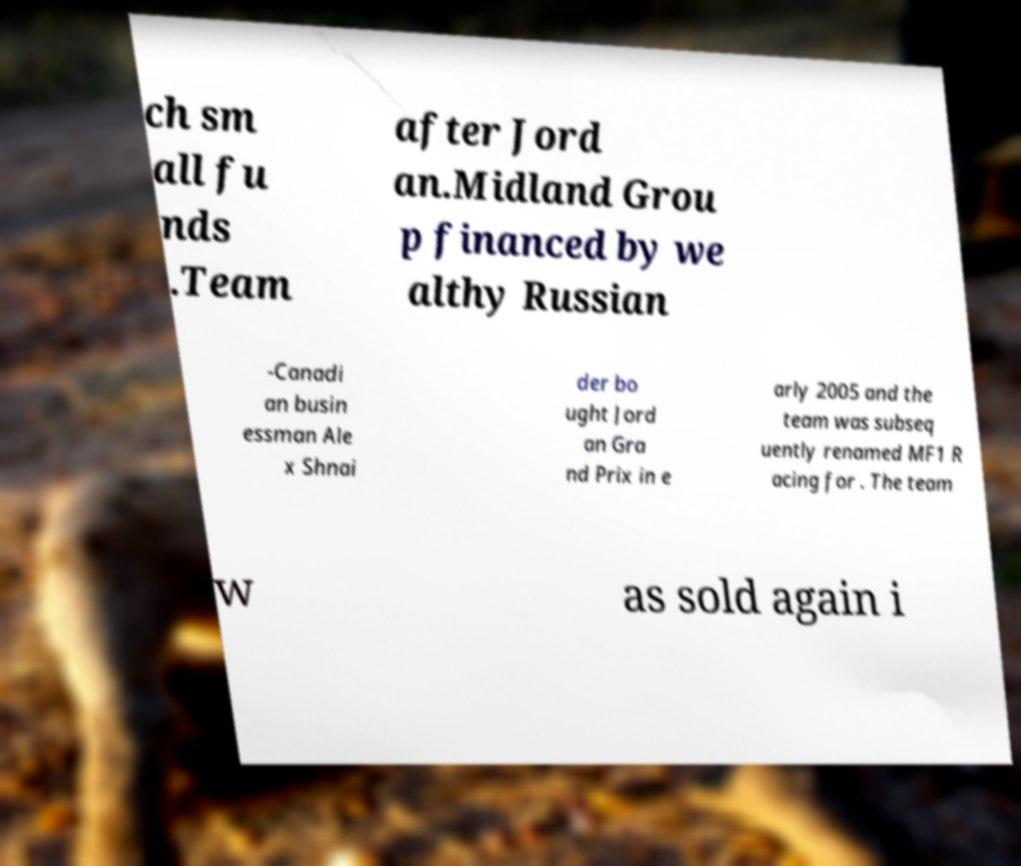What messages or text are displayed in this image? I need them in a readable, typed format. ch sm all fu nds .Team after Jord an.Midland Grou p financed by we althy Russian -Canadi an busin essman Ale x Shnai der bo ught Jord an Gra nd Prix in e arly 2005 and the team was subseq uently renamed MF1 R acing for . The team w as sold again i 